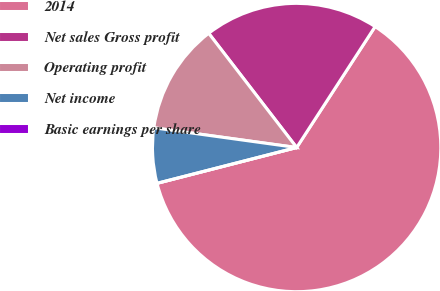<chart> <loc_0><loc_0><loc_500><loc_500><pie_chart><fcel>2014<fcel>Net sales Gross profit<fcel>Operating profit<fcel>Net income<fcel>Basic earnings per share<nl><fcel>61.84%<fcel>19.6%<fcel>12.37%<fcel>6.18%<fcel>0.0%<nl></chart> 